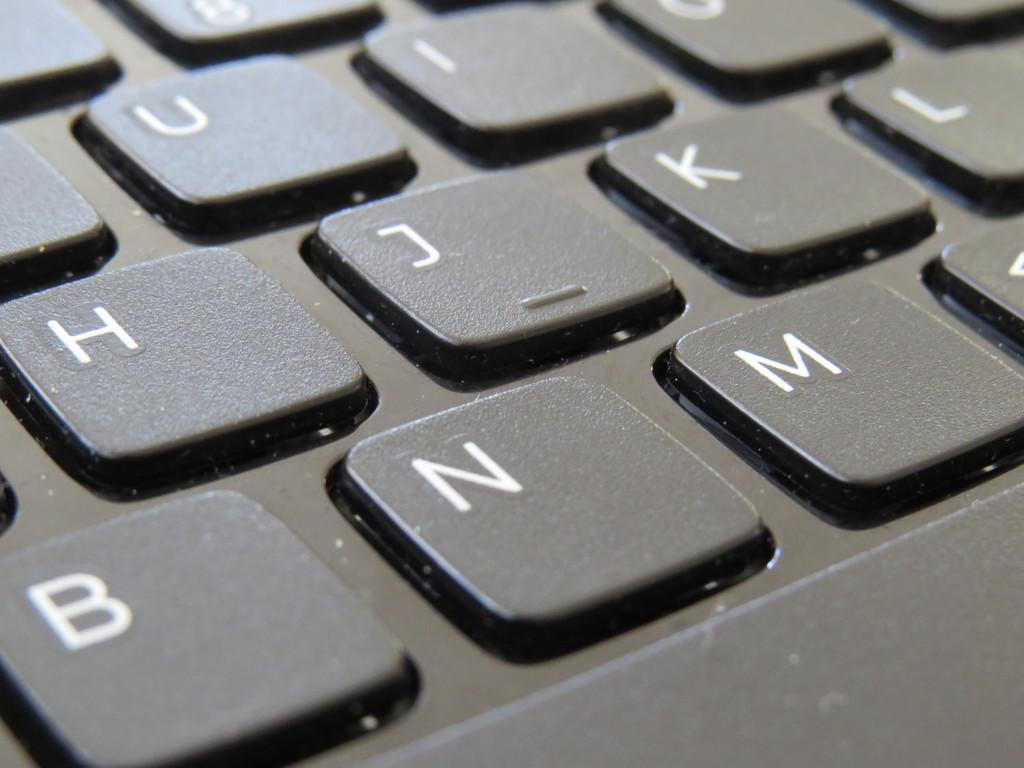What letter is to the left of l?
Provide a short and direct response. U. What is the closest letter to the left?
Provide a short and direct response. B. 